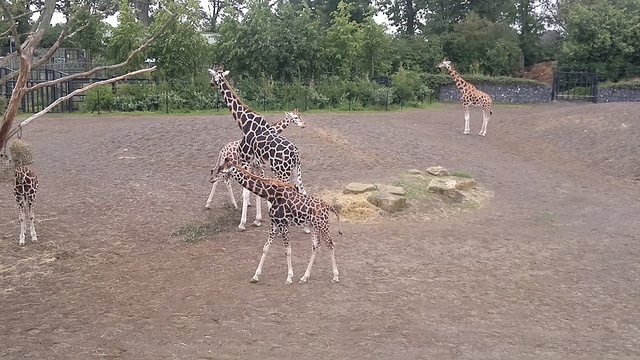Describe the objects in this image and their specific colors. I can see giraffe in gray, darkgray, and lightgray tones, giraffe in gray, lightgray, darkgray, and black tones, giraffe in gray, darkgray, lightgray, and black tones, giraffe in gray, darkgray, pink, and lightgray tones, and giraffe in gray, darkgray, and black tones in this image. 